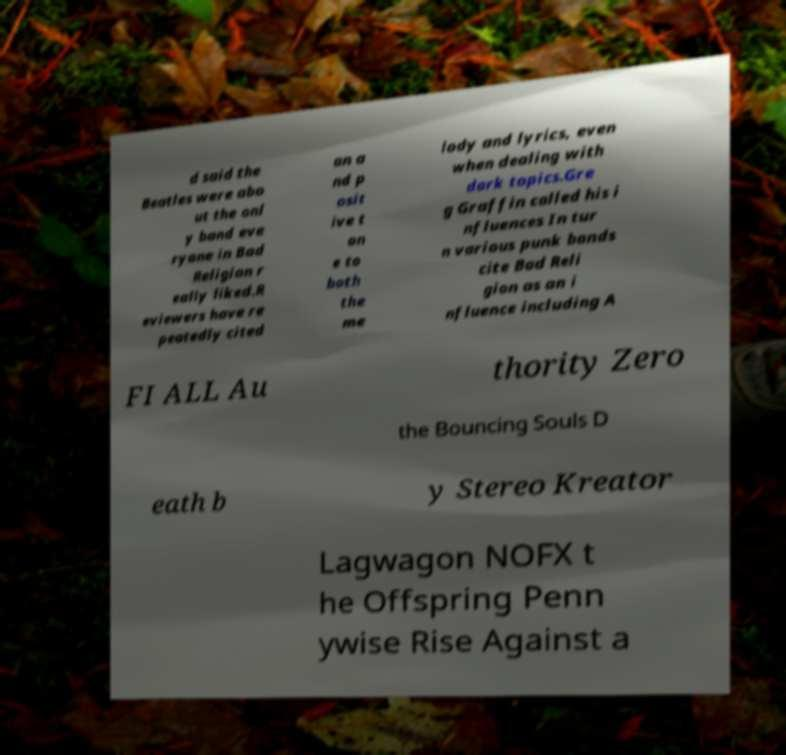I need the written content from this picture converted into text. Can you do that? d said the Beatles were abo ut the onl y band eve ryone in Bad Religion r eally liked.R eviewers have re peatedly cited an a nd p osit ive t on e to both the me lody and lyrics, even when dealing with dark topics.Gre g Graffin called his i nfluences In tur n various punk bands cite Bad Reli gion as an i nfluence including A FI ALL Au thority Zero the Bouncing Souls D eath b y Stereo Kreator Lagwagon NOFX t he Offspring Penn ywise Rise Against a 